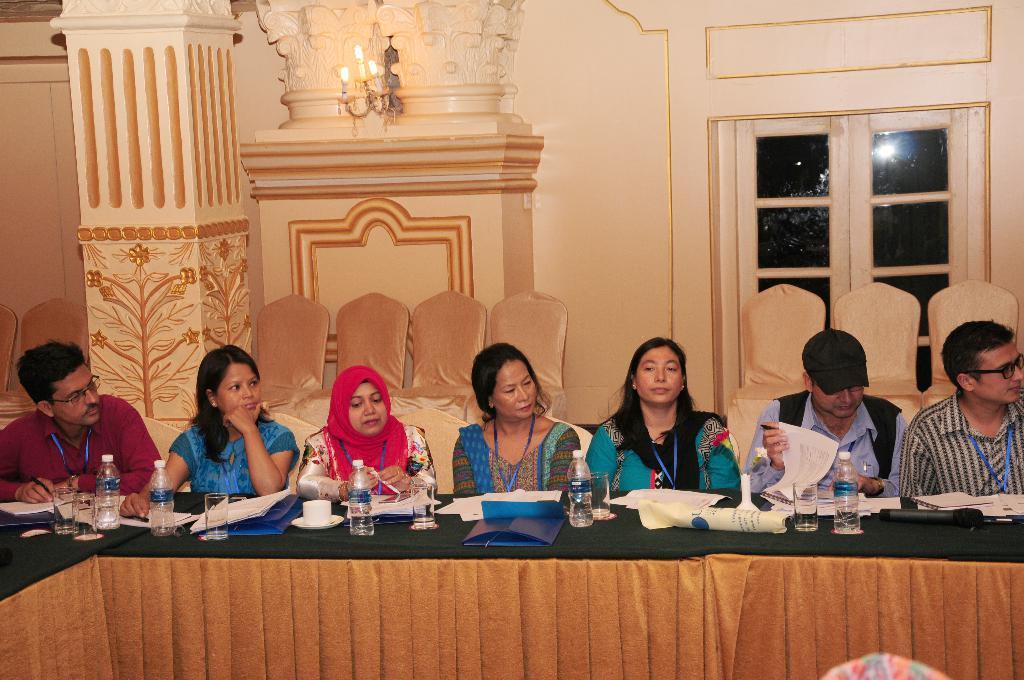Can you describe this image briefly? In the picture there are few women and men sat on chair in front of table. It looks like a meeting hall,there is a chandelier to the wall and there is a door on the right side with chairs in front of them and there are designs on the pillar which is on the right side. 